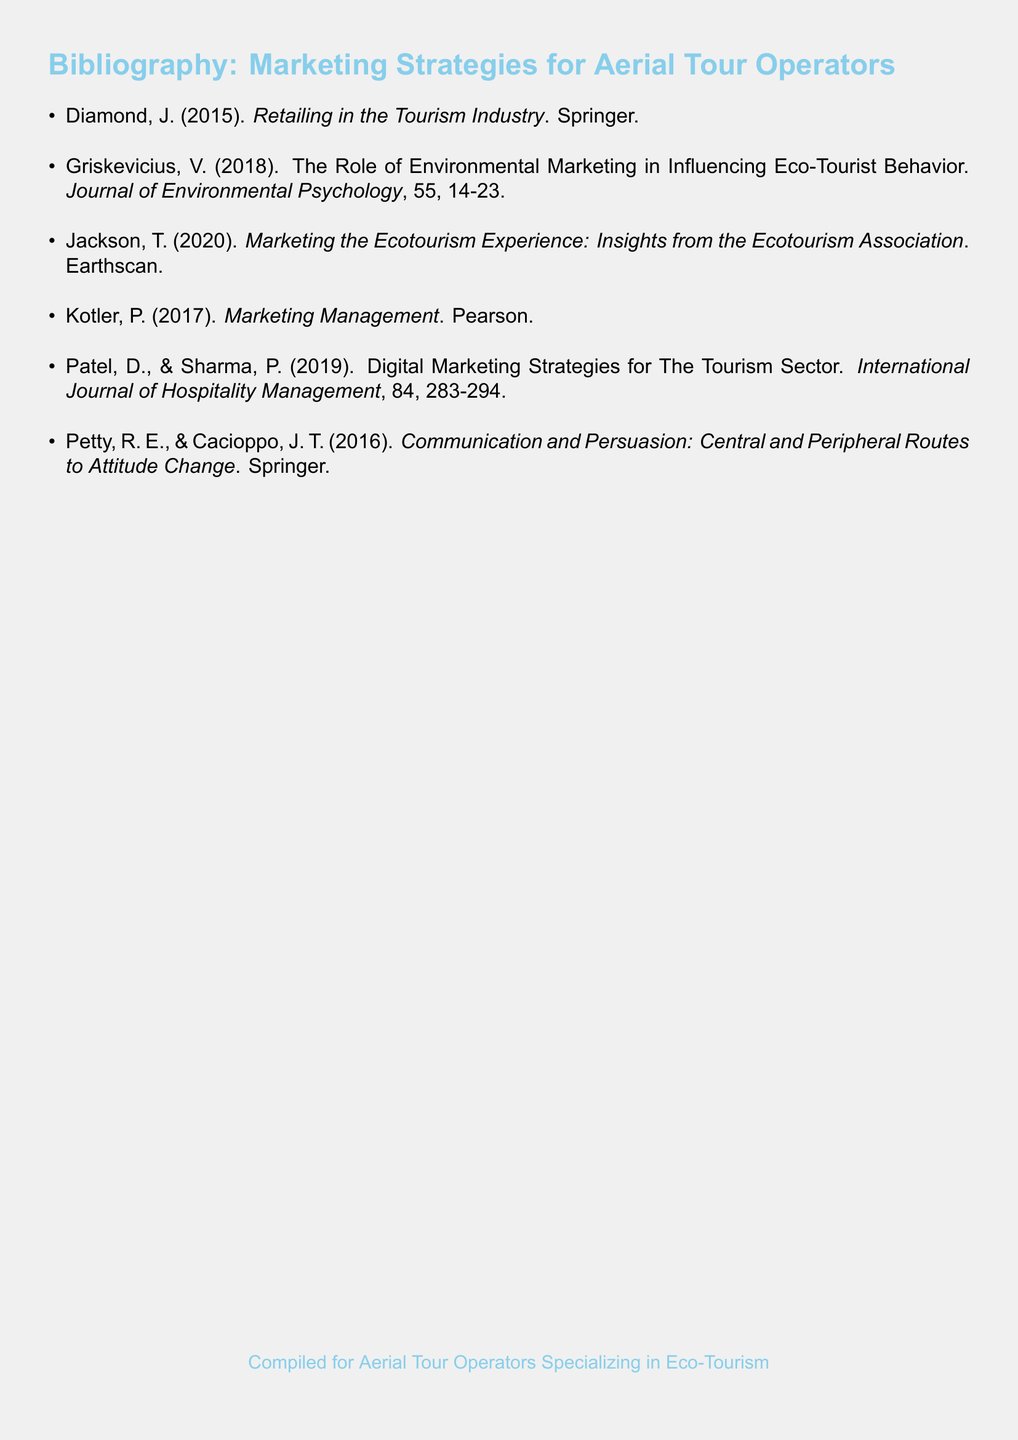what is the title of the document? The title appears at the top of the rendered document, clearly stated as "Bibliography: Marketing Strategies for Aerial Tour Operators."
Answer: Bibliography: Marketing Strategies for Aerial Tour Operators who is the author of the book published in 2015? The publication year and author are listed next to the title of the book, which is "Retailing in the Tourism Industry."
Answer: Diamond what is the main focus of Griskevicius's 2018 paper? The main focus is described in the title of the paper, which includes the influence of environmental marketing on eco-tourist behavior.
Answer: Environmental marketing how many articles are referenced in the bibliography? By counting the items listed, we can determine the total number of references provided.
Answer: 6 which publication discusses digital marketing strategies? The paper that specifically focuses on digital marketing strategies provides insights into practices relevant to the tourism sector.
Answer: Patel & Sharma what is the publication year of the book by Kotler? The year of publication is mentioned next to the author's name and book title in the bibliography.
Answer: 2017 who are the authors of the communication and persuasion book? The authors' names are listed directly next to the title, making it straightforward to identify them.
Answer: Petty & Cacioppo which journal features the work of Griskevicius? The name of the journal is indicated in the citation for Griskevicius's 2018 paper, where it is mentioned alongside the issue and page numbers.
Answer: Journal of Environmental Psychology 